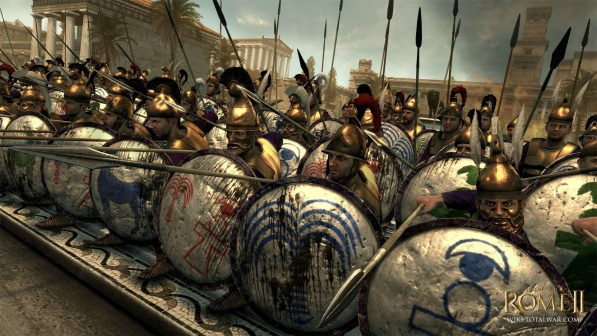Write a detailed description of the given image. This image features a vivid depiction from the video game Rome II: Total War, showcasing a dynamic military formation. In the foreground, we see a tightly-knit group of Roman soldiers in a classical phalanx setup. Each soldier is equipped with a heavy shield ornately decorated with blue and white motifs, suggesting a unit of particular distinction, possibly a praetorian guard. Their helmets, adorned with plumes, catch the light, adding to the drama of the scene.

The soldiers hold long spears that angle slightly upwards, poised for combat, indicating they are either in the midst of a battle or preparing for an imminent threat. The background features impressively detailed ancient Roman architecture, creating a deep sense of historical ambiance. This strategic positioning between formidable architecture and the disciplined ranks speaks to the game's commitment to historical accuracy and atmospheric depth. 